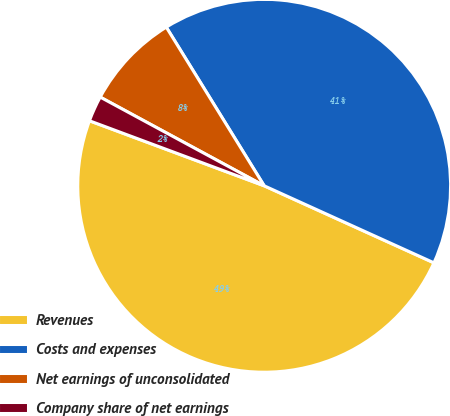<chart> <loc_0><loc_0><loc_500><loc_500><pie_chart><fcel>Revenues<fcel>Costs and expenses<fcel>Net earnings of unconsolidated<fcel>Company share of net earnings<nl><fcel>48.89%<fcel>40.58%<fcel>8.31%<fcel>2.22%<nl></chart> 